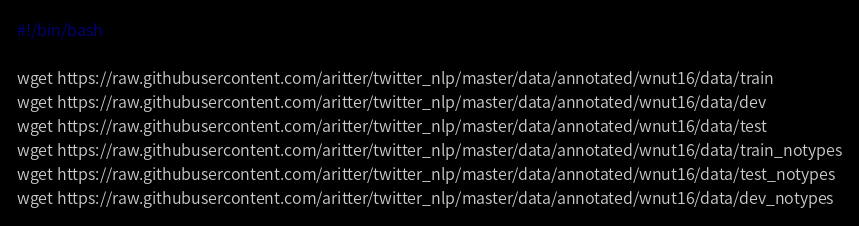Convert code to text. <code><loc_0><loc_0><loc_500><loc_500><_Bash_>#!/bin/bash

wget https://raw.githubusercontent.com/aritter/twitter_nlp/master/data/annotated/wnut16/data/train
wget https://raw.githubusercontent.com/aritter/twitter_nlp/master/data/annotated/wnut16/data/dev
wget https://raw.githubusercontent.com/aritter/twitter_nlp/master/data/annotated/wnut16/data/test
wget https://raw.githubusercontent.com/aritter/twitter_nlp/master/data/annotated/wnut16/data/train_notypes
wget https://raw.githubusercontent.com/aritter/twitter_nlp/master/data/annotated/wnut16/data/test_notypes
wget https://raw.githubusercontent.com/aritter/twitter_nlp/master/data/annotated/wnut16/data/dev_notypes
</code> 